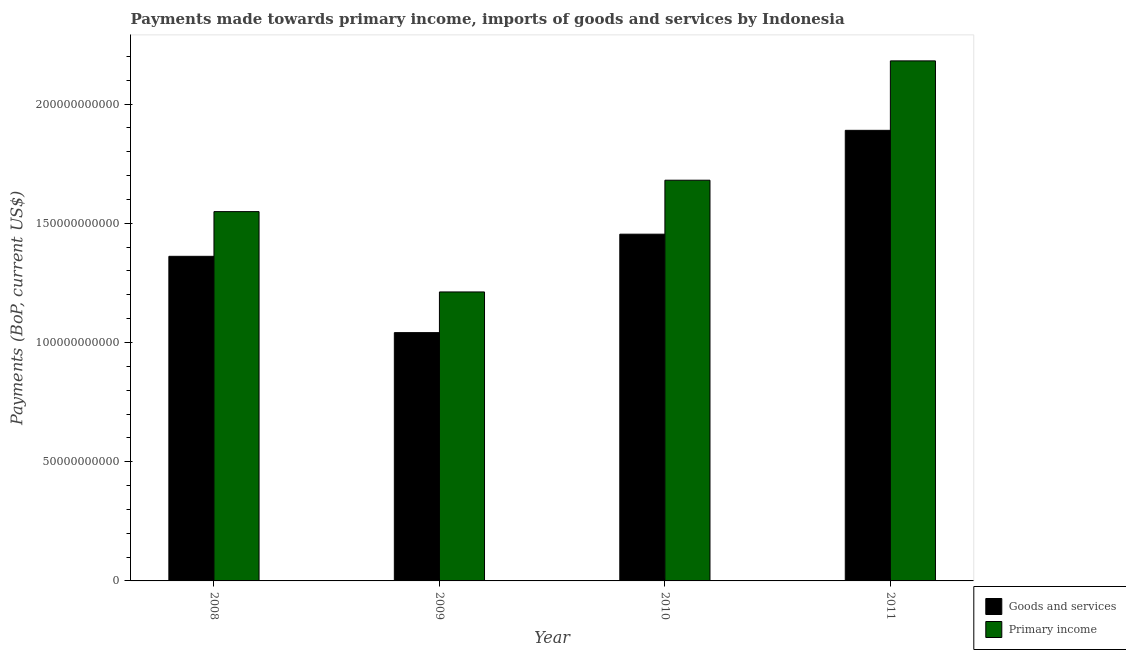How many different coloured bars are there?
Give a very brief answer. 2. How many bars are there on the 3rd tick from the right?
Provide a short and direct response. 2. What is the payments made towards goods and services in 2011?
Ensure brevity in your answer.  1.89e+11. Across all years, what is the maximum payments made towards primary income?
Your response must be concise. 2.18e+11. Across all years, what is the minimum payments made towards primary income?
Your answer should be compact. 1.21e+11. What is the total payments made towards primary income in the graph?
Provide a short and direct response. 6.62e+11. What is the difference between the payments made towards goods and services in 2010 and that in 2011?
Offer a terse response. -4.36e+1. What is the difference between the payments made towards primary income in 2011 and the payments made towards goods and services in 2008?
Give a very brief answer. 6.32e+1. What is the average payments made towards primary income per year?
Provide a short and direct response. 1.66e+11. What is the ratio of the payments made towards primary income in 2009 to that in 2010?
Offer a terse response. 0.72. Is the payments made towards primary income in 2008 less than that in 2011?
Your answer should be compact. Yes. What is the difference between the highest and the second highest payments made towards goods and services?
Your answer should be compact. 4.36e+1. What is the difference between the highest and the lowest payments made towards primary income?
Ensure brevity in your answer.  9.69e+1. What does the 2nd bar from the left in 2010 represents?
Your response must be concise. Primary income. What does the 2nd bar from the right in 2011 represents?
Provide a succinct answer. Goods and services. Does the graph contain any zero values?
Keep it short and to the point. No. Does the graph contain grids?
Your answer should be very brief. No. Where does the legend appear in the graph?
Offer a terse response. Bottom right. How many legend labels are there?
Offer a very short reply. 2. How are the legend labels stacked?
Your answer should be very brief. Vertical. What is the title of the graph?
Keep it short and to the point. Payments made towards primary income, imports of goods and services by Indonesia. Does "Largest city" appear as one of the legend labels in the graph?
Give a very brief answer. No. What is the label or title of the X-axis?
Provide a short and direct response. Year. What is the label or title of the Y-axis?
Give a very brief answer. Payments (BoP, current US$). What is the Payments (BoP, current US$) of Goods and services in 2008?
Keep it short and to the point. 1.36e+11. What is the Payments (BoP, current US$) in Primary income in 2008?
Provide a succinct answer. 1.55e+11. What is the Payments (BoP, current US$) in Goods and services in 2009?
Keep it short and to the point. 1.04e+11. What is the Payments (BoP, current US$) in Primary income in 2009?
Provide a short and direct response. 1.21e+11. What is the Payments (BoP, current US$) of Goods and services in 2010?
Give a very brief answer. 1.45e+11. What is the Payments (BoP, current US$) of Primary income in 2010?
Provide a succinct answer. 1.68e+11. What is the Payments (BoP, current US$) of Goods and services in 2011?
Provide a succinct answer. 1.89e+11. What is the Payments (BoP, current US$) of Primary income in 2011?
Ensure brevity in your answer.  2.18e+11. Across all years, what is the maximum Payments (BoP, current US$) of Goods and services?
Offer a terse response. 1.89e+11. Across all years, what is the maximum Payments (BoP, current US$) of Primary income?
Your answer should be compact. 2.18e+11. Across all years, what is the minimum Payments (BoP, current US$) of Goods and services?
Your answer should be very brief. 1.04e+11. Across all years, what is the minimum Payments (BoP, current US$) in Primary income?
Provide a succinct answer. 1.21e+11. What is the total Payments (BoP, current US$) of Goods and services in the graph?
Your answer should be compact. 5.75e+11. What is the total Payments (BoP, current US$) of Primary income in the graph?
Offer a terse response. 6.62e+11. What is the difference between the Payments (BoP, current US$) in Goods and services in 2008 and that in 2009?
Keep it short and to the point. 3.20e+1. What is the difference between the Payments (BoP, current US$) of Primary income in 2008 and that in 2009?
Keep it short and to the point. 3.37e+1. What is the difference between the Payments (BoP, current US$) in Goods and services in 2008 and that in 2010?
Ensure brevity in your answer.  -9.29e+09. What is the difference between the Payments (BoP, current US$) of Primary income in 2008 and that in 2010?
Your answer should be very brief. -1.32e+1. What is the difference between the Payments (BoP, current US$) of Goods and services in 2008 and that in 2011?
Offer a terse response. -5.28e+1. What is the difference between the Payments (BoP, current US$) in Primary income in 2008 and that in 2011?
Your answer should be very brief. -6.32e+1. What is the difference between the Payments (BoP, current US$) in Goods and services in 2009 and that in 2010?
Offer a very short reply. -4.13e+1. What is the difference between the Payments (BoP, current US$) in Primary income in 2009 and that in 2010?
Your response must be concise. -4.69e+1. What is the difference between the Payments (BoP, current US$) in Goods and services in 2009 and that in 2011?
Ensure brevity in your answer.  -8.48e+1. What is the difference between the Payments (BoP, current US$) in Primary income in 2009 and that in 2011?
Give a very brief answer. -9.69e+1. What is the difference between the Payments (BoP, current US$) in Goods and services in 2010 and that in 2011?
Offer a terse response. -4.36e+1. What is the difference between the Payments (BoP, current US$) in Primary income in 2010 and that in 2011?
Your answer should be compact. -5.00e+1. What is the difference between the Payments (BoP, current US$) of Goods and services in 2008 and the Payments (BoP, current US$) of Primary income in 2009?
Ensure brevity in your answer.  1.49e+1. What is the difference between the Payments (BoP, current US$) in Goods and services in 2008 and the Payments (BoP, current US$) in Primary income in 2010?
Give a very brief answer. -3.19e+1. What is the difference between the Payments (BoP, current US$) of Goods and services in 2008 and the Payments (BoP, current US$) of Primary income in 2011?
Provide a succinct answer. -8.20e+1. What is the difference between the Payments (BoP, current US$) in Goods and services in 2009 and the Payments (BoP, current US$) in Primary income in 2010?
Your answer should be very brief. -6.39e+1. What is the difference between the Payments (BoP, current US$) in Goods and services in 2009 and the Payments (BoP, current US$) in Primary income in 2011?
Give a very brief answer. -1.14e+11. What is the difference between the Payments (BoP, current US$) in Goods and services in 2010 and the Payments (BoP, current US$) in Primary income in 2011?
Offer a terse response. -7.27e+1. What is the average Payments (BoP, current US$) of Goods and services per year?
Your answer should be very brief. 1.44e+11. What is the average Payments (BoP, current US$) in Primary income per year?
Make the answer very short. 1.66e+11. In the year 2008, what is the difference between the Payments (BoP, current US$) in Goods and services and Payments (BoP, current US$) in Primary income?
Make the answer very short. -1.87e+1. In the year 2009, what is the difference between the Payments (BoP, current US$) of Goods and services and Payments (BoP, current US$) of Primary income?
Make the answer very short. -1.71e+1. In the year 2010, what is the difference between the Payments (BoP, current US$) in Goods and services and Payments (BoP, current US$) in Primary income?
Ensure brevity in your answer.  -2.26e+1. In the year 2011, what is the difference between the Payments (BoP, current US$) in Goods and services and Payments (BoP, current US$) in Primary income?
Give a very brief answer. -2.91e+1. What is the ratio of the Payments (BoP, current US$) of Goods and services in 2008 to that in 2009?
Keep it short and to the point. 1.31. What is the ratio of the Payments (BoP, current US$) in Primary income in 2008 to that in 2009?
Ensure brevity in your answer.  1.28. What is the ratio of the Payments (BoP, current US$) of Goods and services in 2008 to that in 2010?
Your response must be concise. 0.94. What is the ratio of the Payments (BoP, current US$) of Primary income in 2008 to that in 2010?
Provide a short and direct response. 0.92. What is the ratio of the Payments (BoP, current US$) of Goods and services in 2008 to that in 2011?
Your answer should be compact. 0.72. What is the ratio of the Payments (BoP, current US$) in Primary income in 2008 to that in 2011?
Make the answer very short. 0.71. What is the ratio of the Payments (BoP, current US$) of Goods and services in 2009 to that in 2010?
Provide a succinct answer. 0.72. What is the ratio of the Payments (BoP, current US$) of Primary income in 2009 to that in 2010?
Provide a succinct answer. 0.72. What is the ratio of the Payments (BoP, current US$) of Goods and services in 2009 to that in 2011?
Give a very brief answer. 0.55. What is the ratio of the Payments (BoP, current US$) of Primary income in 2009 to that in 2011?
Your response must be concise. 0.56. What is the ratio of the Payments (BoP, current US$) in Goods and services in 2010 to that in 2011?
Offer a terse response. 0.77. What is the ratio of the Payments (BoP, current US$) in Primary income in 2010 to that in 2011?
Give a very brief answer. 0.77. What is the difference between the highest and the second highest Payments (BoP, current US$) of Goods and services?
Your answer should be very brief. 4.36e+1. What is the difference between the highest and the second highest Payments (BoP, current US$) of Primary income?
Provide a short and direct response. 5.00e+1. What is the difference between the highest and the lowest Payments (BoP, current US$) in Goods and services?
Offer a very short reply. 8.48e+1. What is the difference between the highest and the lowest Payments (BoP, current US$) in Primary income?
Offer a terse response. 9.69e+1. 